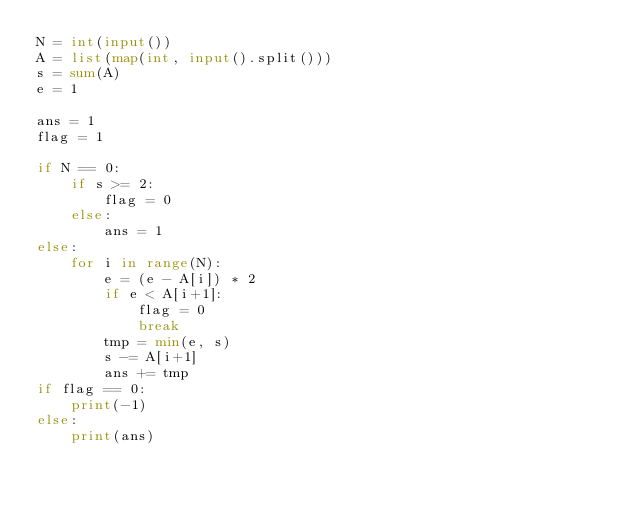Convert code to text. <code><loc_0><loc_0><loc_500><loc_500><_Python_>N = int(input())
A = list(map(int, input().split()))
s = sum(A)
e = 1

ans = 1
flag = 1

if N == 0:
    if s >= 2:
        flag = 0
    else:
        ans = 1
else:
    for i in range(N):
        e = (e - A[i]) * 2
        if e < A[i+1]:
            flag = 0
            break
        tmp = min(e, s)
        s -= A[i+1]
        ans += tmp
if flag == 0:
    print(-1)
else:
    print(ans)</code> 